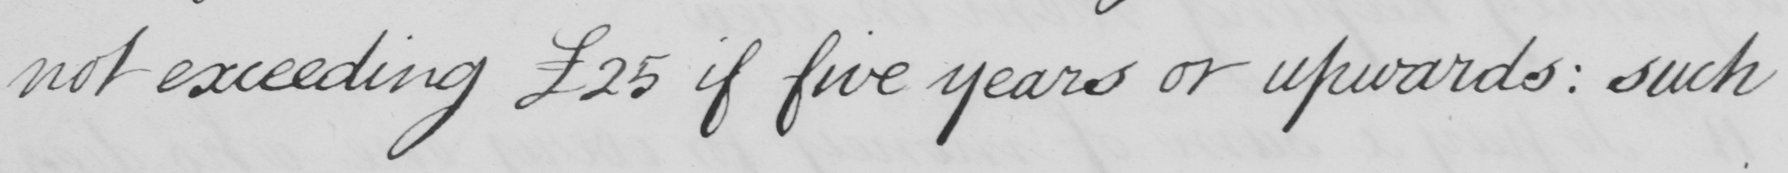What text is written in this handwritten line? not exceeding £25 if five years or upwards :  such 